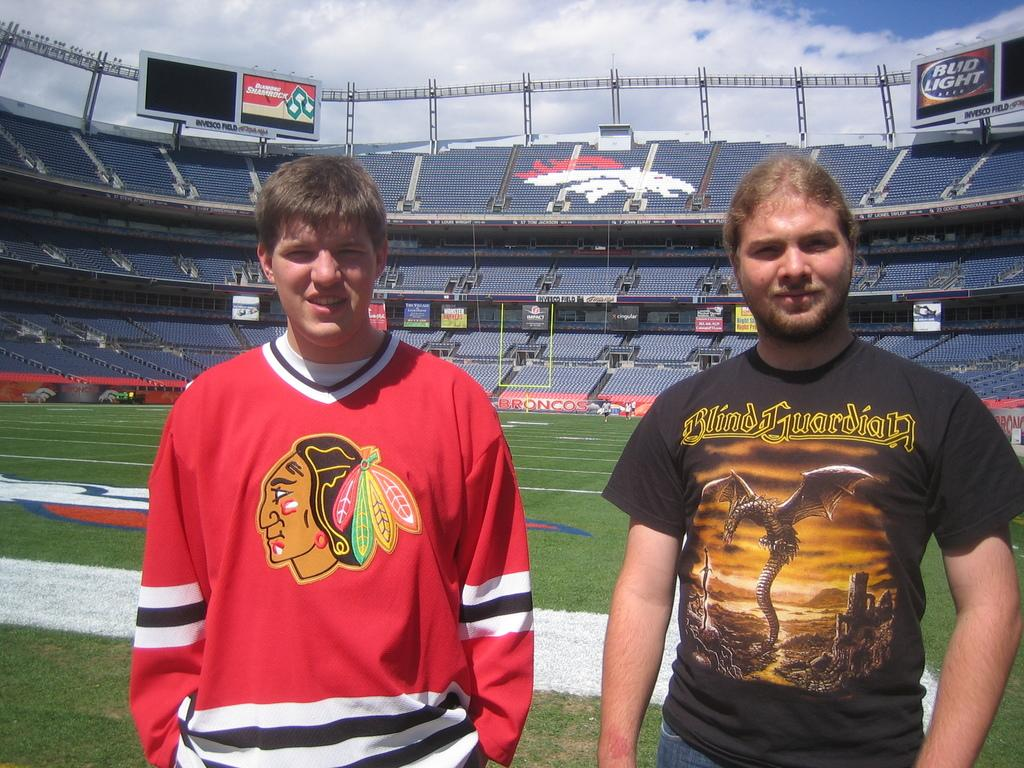Provide a one-sentence caption for the provided image. A boy wearing a Blackhawks jersey stands on the Denver Broncos field. 